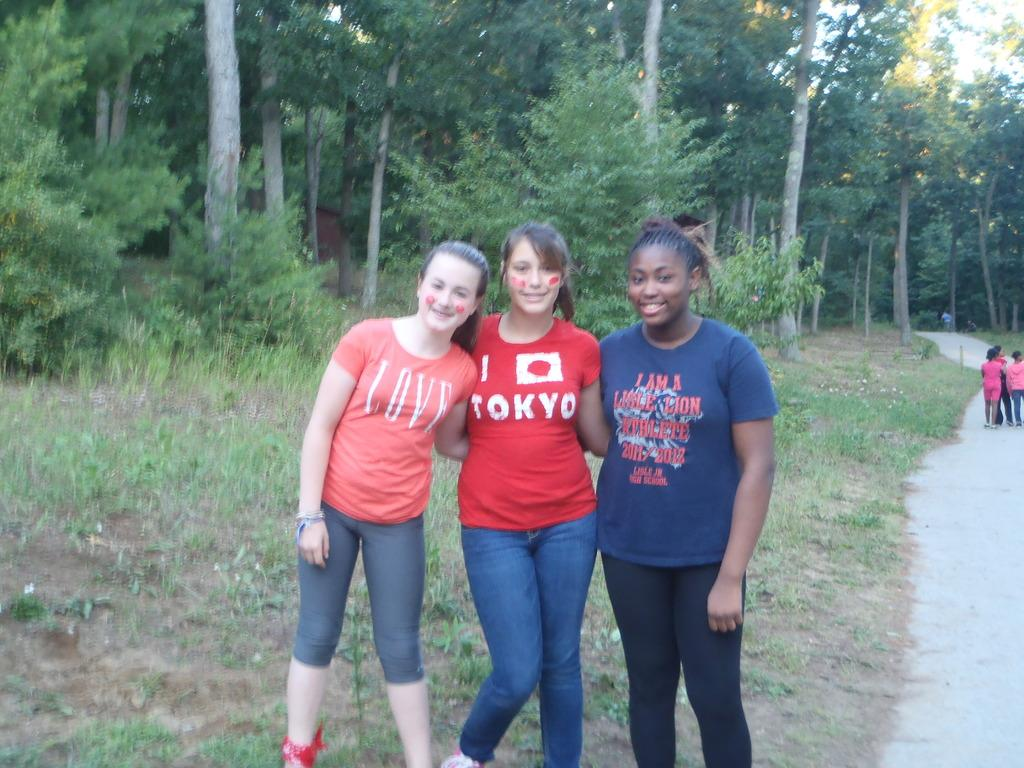What is happening on the ground in the image? There are people on the ground in the image. What type of pathway can be seen in the image? There is a road visible in the image. What is the surface that the people are standing on? The ground with grass is present in the image. What type of vegetation is visible in the image? There are plants and trees visible in the image. What part of the natural environment is visible in the image? The sky is visible in the image. What is the name of the daughter of the person standing on the grass in the image? There is no information about the names of individuals in the image, nor is there any mention of a daughter. 